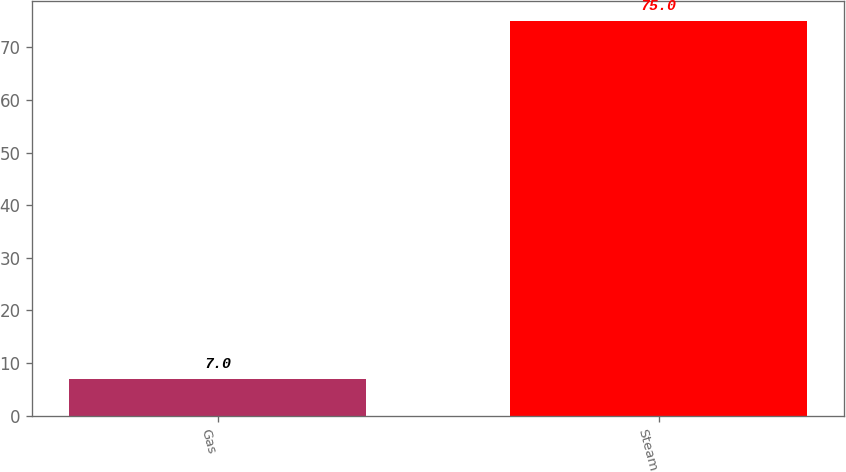<chart> <loc_0><loc_0><loc_500><loc_500><bar_chart><fcel>Gas<fcel>Steam<nl><fcel>7<fcel>75<nl></chart> 